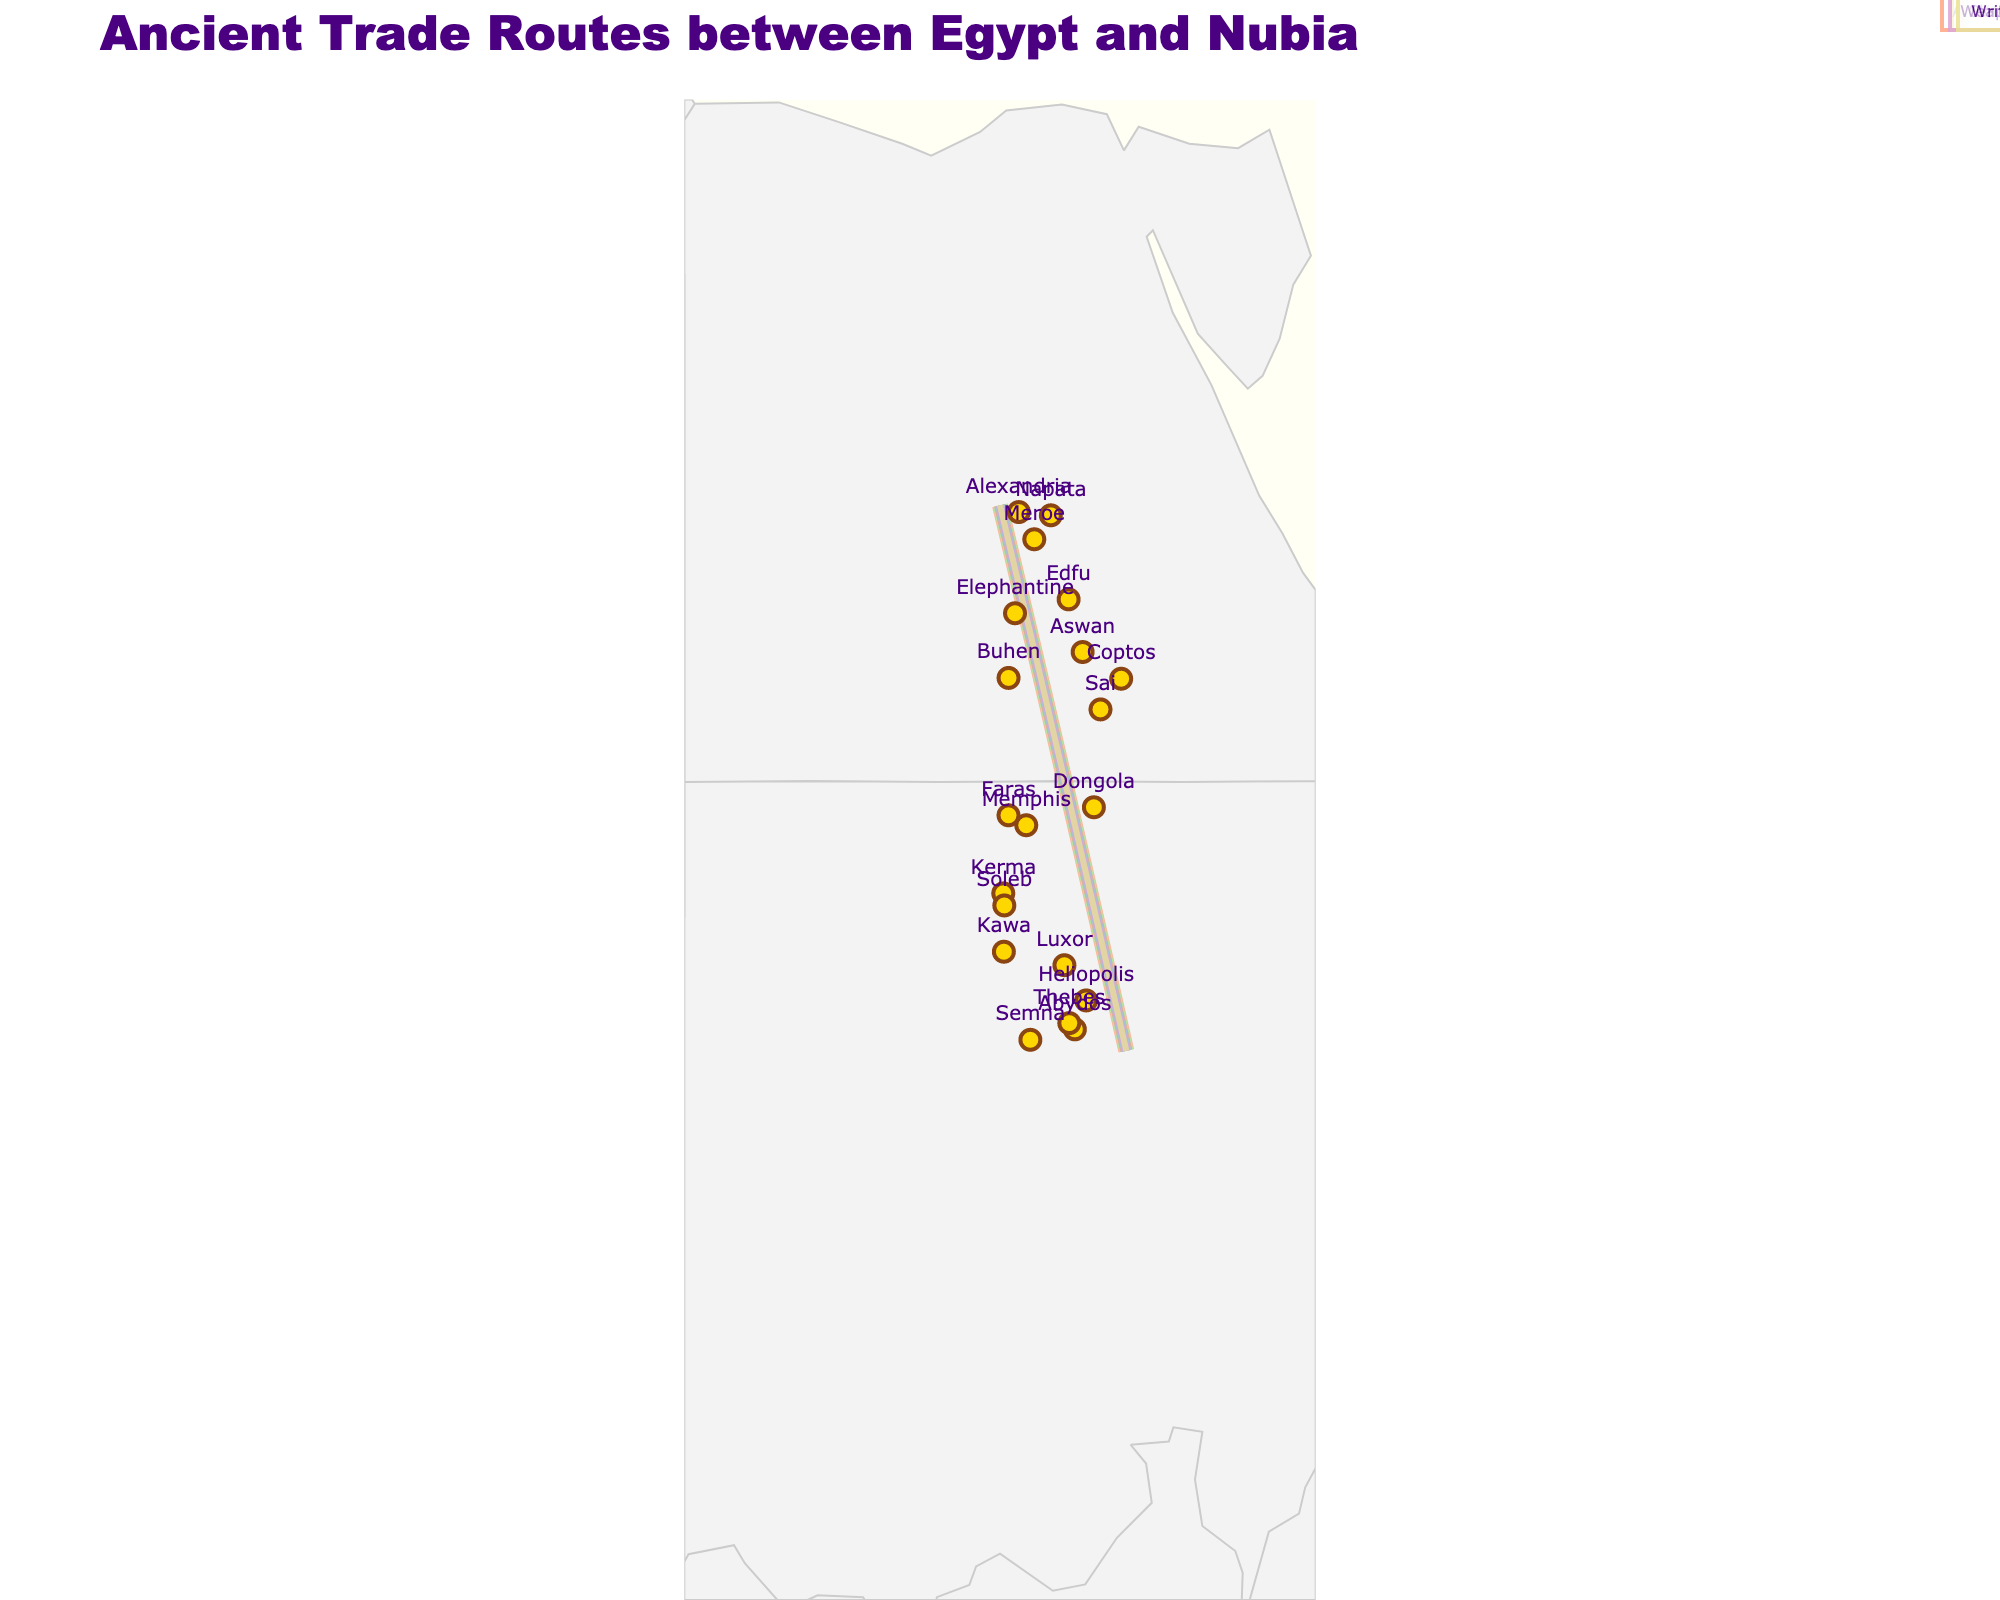How many trade routes are depicted in the figure? Count the number of different lines representing trade routes between cities. There are a total of 10 trade routes.
Answer: 10 Which city in Egypt is connected to the most destinations in Nubia? Check for the Egyptian city that appears multiple times as an origin. Thebes is connected to one destination in Nubia: Kerma. Memphis is connected to one destination: Napata. Aswan is connected to one destination: Meroe, and so on. None of the Egyptian cities appear more than once as origin, indicating an equal number of connections.
Answer: All cities are equally connected to one destination each Which route depicts a high trade volume? Identify the route with the largest width of the trade line. The route Thebes to Kerma has the widest line representing the highest trade volume of 8.
Answer: Thebes to Kerma What is the total trade volume of all routes combined? Sum the trade volume values of all routes: 8 (Thebes-Kerma) + 7 (Memphis-Napata) + 6 (Aswan-Meroe) + 5 (Elephantine-Dongola) + 4 (Edfu-Faras) + 6 (Luxor-Kawa) + 3 (Abydos-Buhen) + 5 (Coptos-Sai) + 4 (Heliopolis-Semna) + 3 (Alexandria-Soleb). This equals 51.
Answer: 51 Which route includes the cultural exchange of 'Pottery'? Look for the annotation with 'Pottery'. The route from Aswan to Meroe describes a cultural exchange involving 'Pottery'.
Answer: Aswan to Meroe Considering the trade of goods, identify a route that involves the exchange of precious metals. Find the annotation with goods related to precious metals. The route from Luxor to Kawa involves the trade of 'Copper'.
Answer: Luxor to Kawa Comparing the trade routes involving perfumes and papyrus, which route has a higher trade volume? Identify the trade volume of the routes involving 'Perfumes' (Heliopolis-Semna) and 'Papyrus' (Alexandria-Soleb) from their lines and annotations. Heliopolis-Semna has a trade volume of 4, whereas Alexandria-Soleb has a trade volume of 3.
Answer: Heliopolis to Semna Which routes involve the exchange of animal-based goods? Look for annotations detailing animal-based goods. The routes involving animal-based goods are: Memphis to Napata (Ivory) and Abydos to Buhen (Cattle).
Answer: Memphis to Napata and Abydos to Buhen What cultural exchanges are associated with the trade route between Thebes and Kerma? Refer to the annotation linked to this route. It shows that the cultural exchange includes 'Architecture'.
Answer: Architecture Of all the routes, which ones have a trade volume of 6 or more? Identify the routes with lines of width 6 or more. These are Thebes to Kerma (8), Memphis to Napata (7), Aswan to Meroe (6), and Luxor to Kawa (6).
Answer: Thebes to Kerma, Memphis to Napata, Aswan to Meroe, Luxor to Kawa 